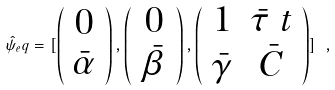Convert formula to latex. <formula><loc_0><loc_0><loc_500><loc_500>\hat { \psi } _ { e } q = [ \left ( \begin{array} { c } 0 \\ \bar { \alpha } \end{array} \right ) , \left ( \begin{array} { c } 0 \\ \bar { \beta } \end{array} \right ) , \left ( \begin{array} { c c } 1 & \bar { \tau } \ t \\ \bar { \gamma } & \bar { C } \\ \end{array} \right ) ] \ ,</formula> 